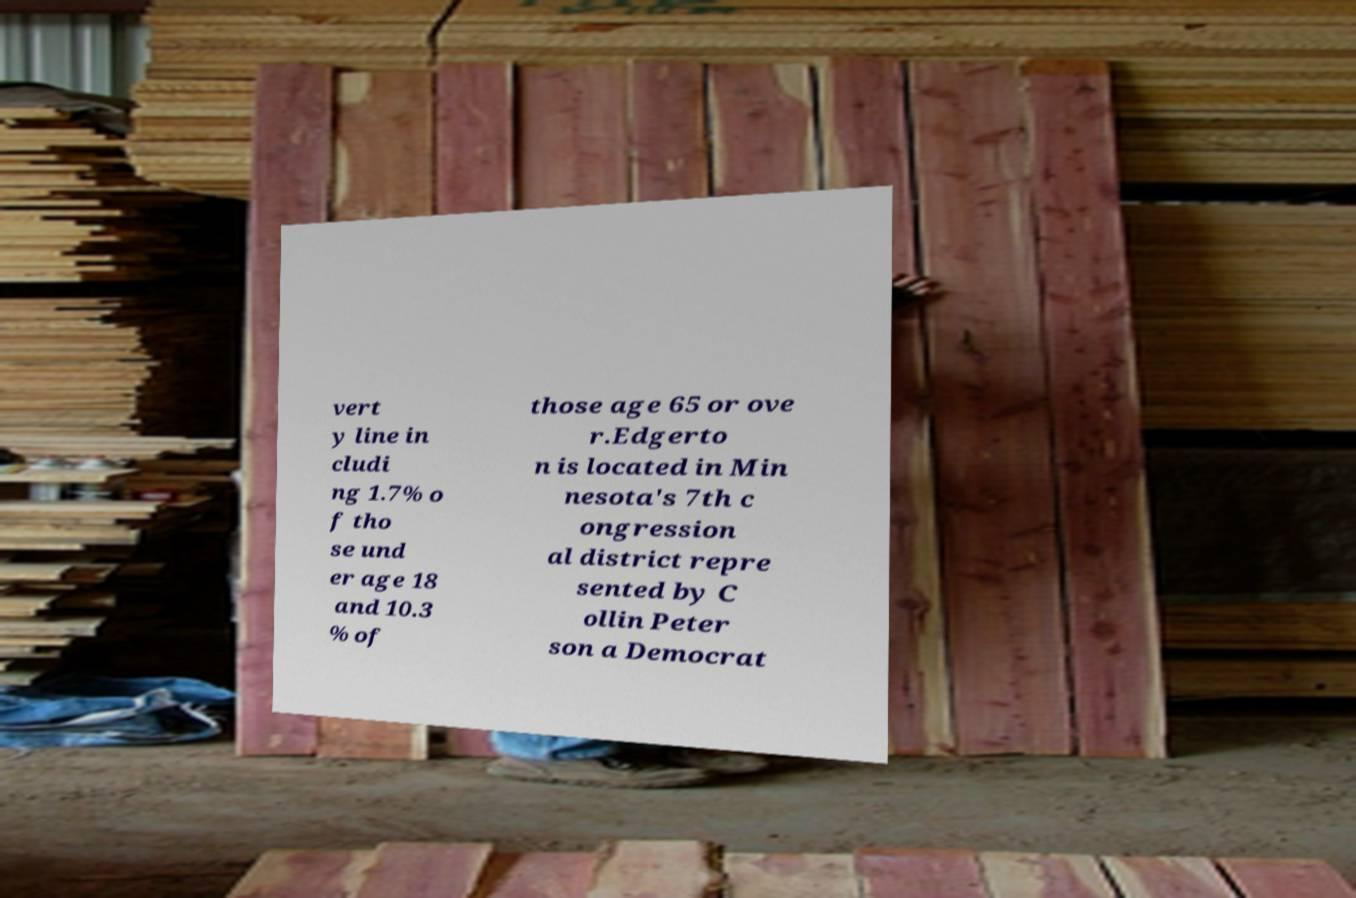Can you accurately transcribe the text from the provided image for me? vert y line in cludi ng 1.7% o f tho se und er age 18 and 10.3 % of those age 65 or ove r.Edgerto n is located in Min nesota's 7th c ongression al district repre sented by C ollin Peter son a Democrat 